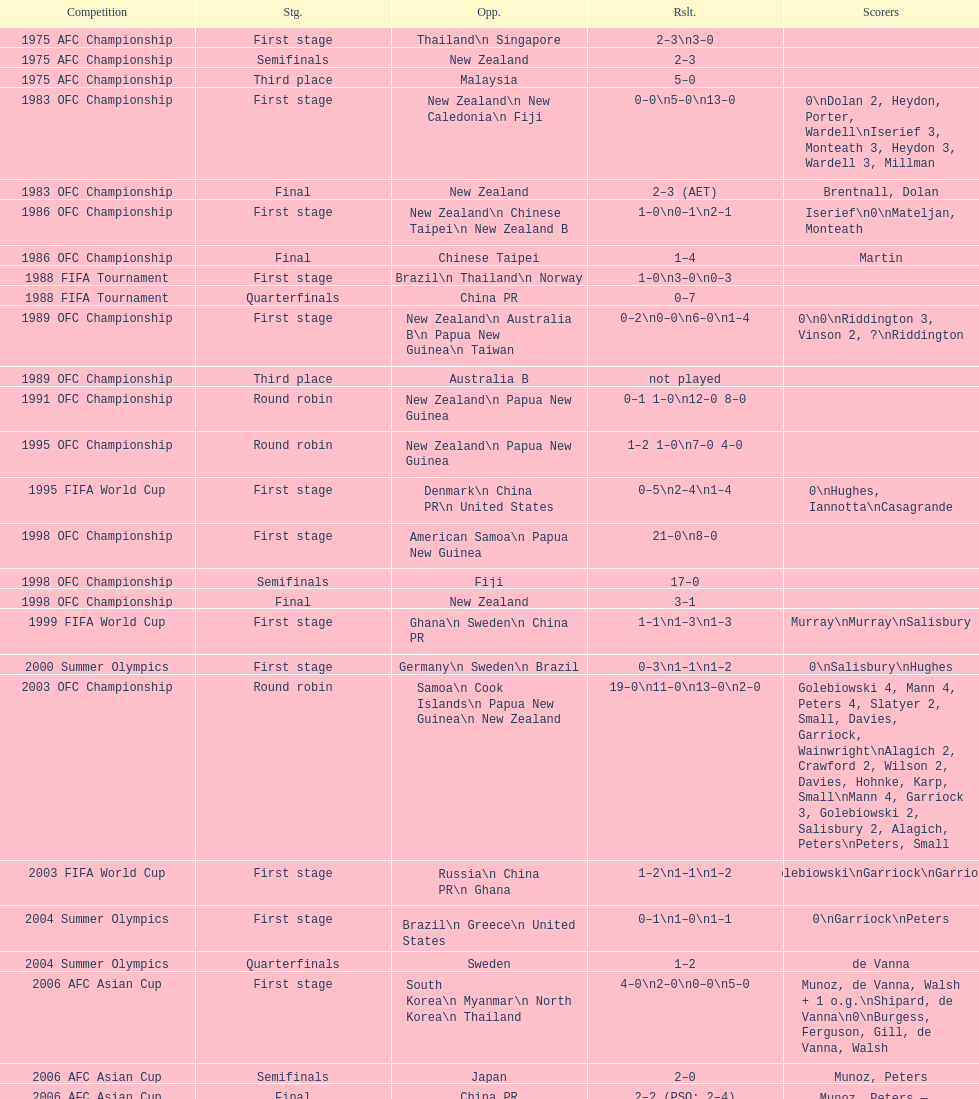What was the total goals made in the 1983 ofc championship? 18. 